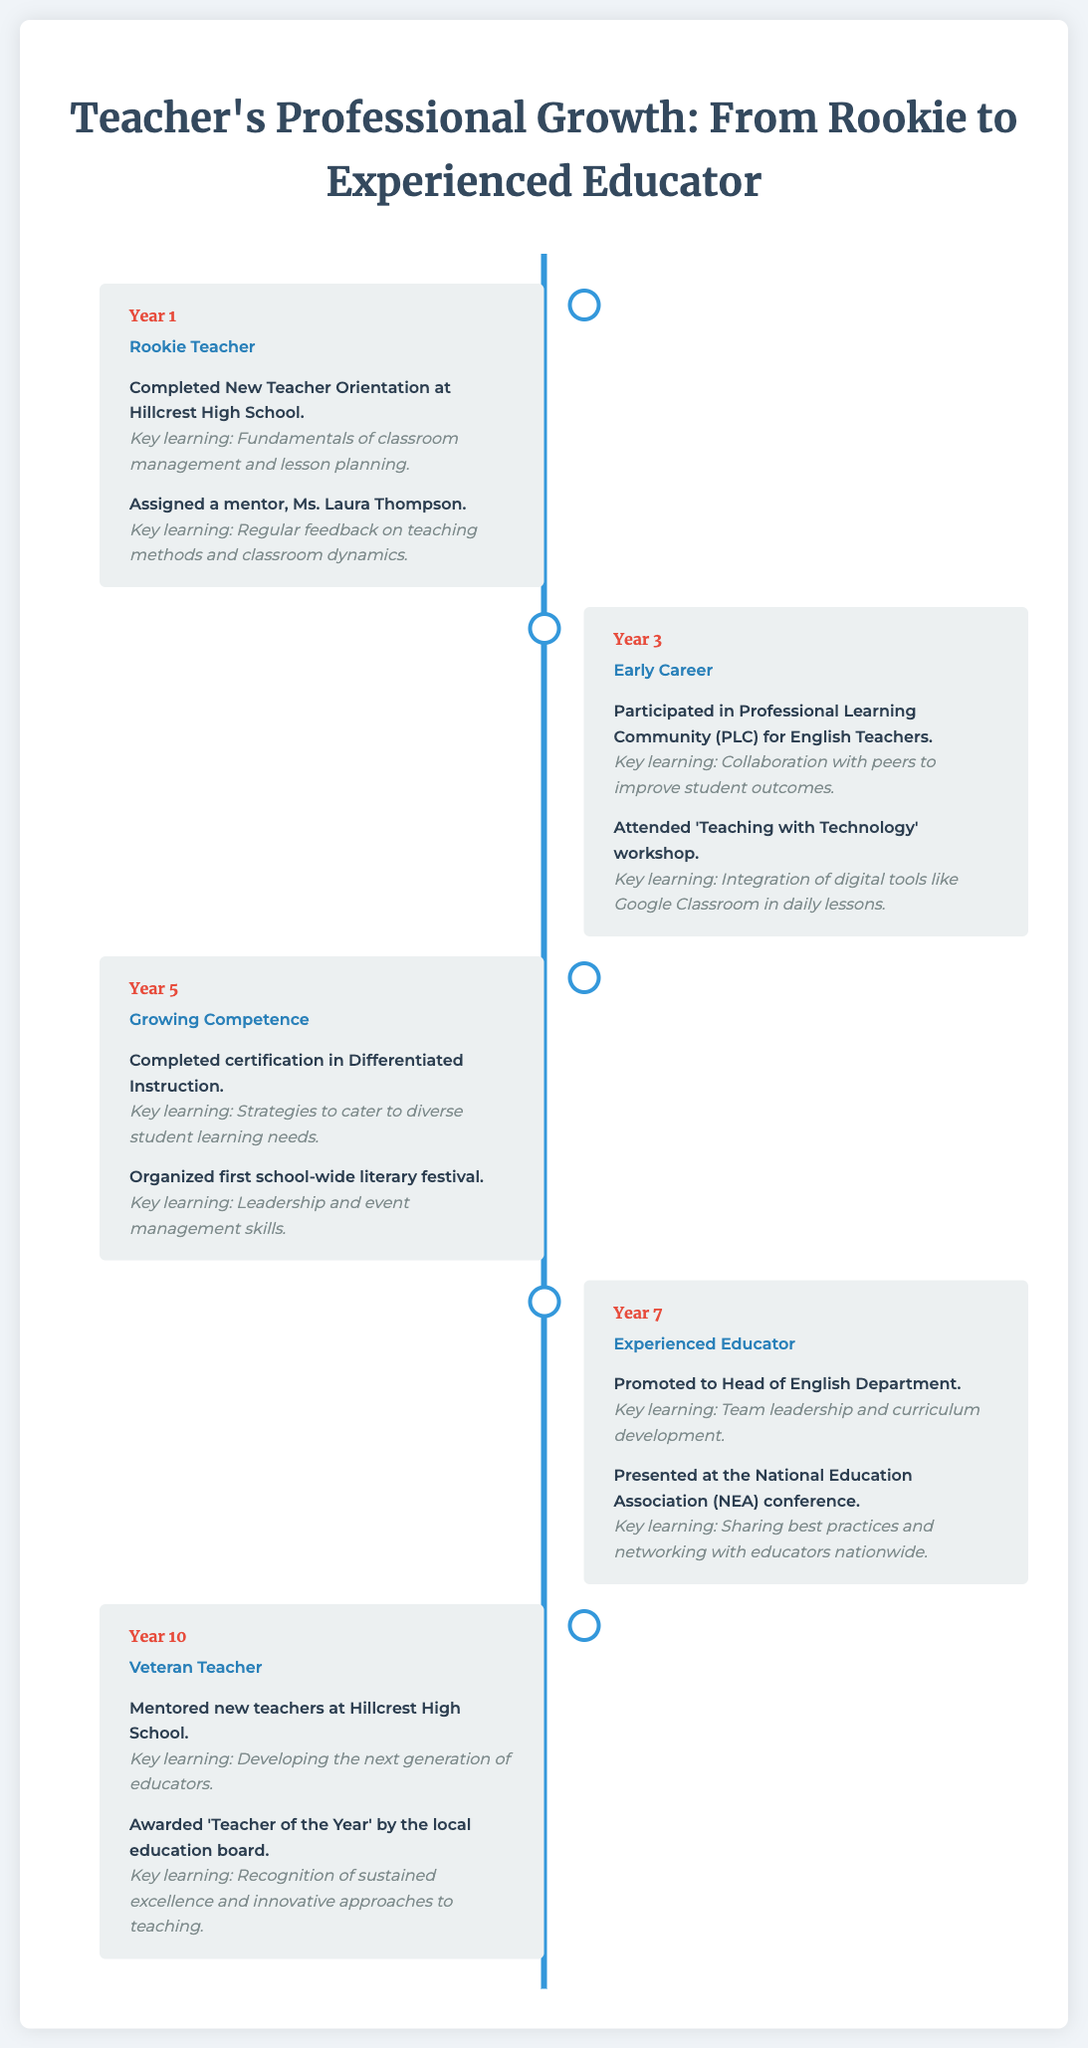What stage is described in Year 1? Year 1 is categorized as "Rookie Teacher" in the timeline.
Answer: Rookie Teacher Who was assigned as a mentor in Year 1? The mentor assigned in Year 1 was Ms. Laura Thompson.
Answer: Ms. Laura Thompson What key learning was emphasized in Year 5? The key learning in Year 5 was about strategies to cater to diverse student learning needs.
Answer: Strategies to cater to diverse student learning needs Which event occurred in Year 7? In Year 7, the teacher was promoted to Head of English Department.
Answer: Promoted to Head of English Department What is the year when the teacher was awarded 'Teacher of the Year'? The award was received in Year 10.
Answer: Year 10 What professional development activity did the teacher participate in during Year 3? In Year 3, the teacher participated in a Professional Learning Community (PLC) for English Teachers.
Answer: Professional Learning Community (PLC) for English Teachers How did the teacher contribute to the school in Year 5? The teacher organized the first school-wide literary festival.
Answer: Organized first school-wide literary festival What is a key learning from the Year 10 events? The key learning from Year 10 emphasizes developing the next generation of educators.
Answer: Developing the next generation of educators 